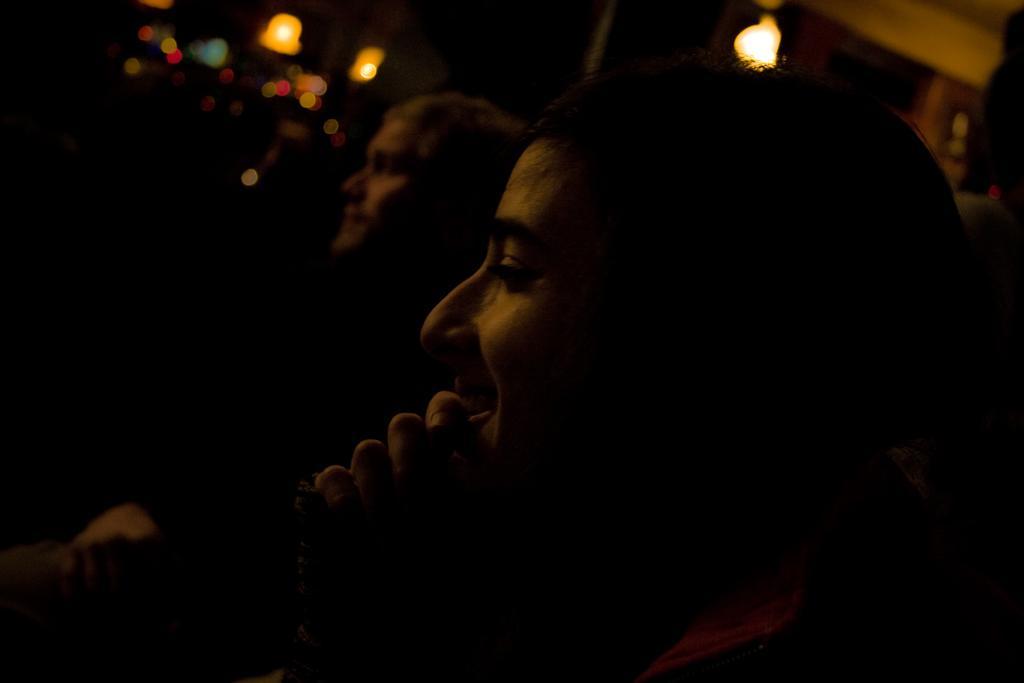Could you give a brief overview of what you see in this image? In this image we can see some people sitting. On the backside we can see some lights. 